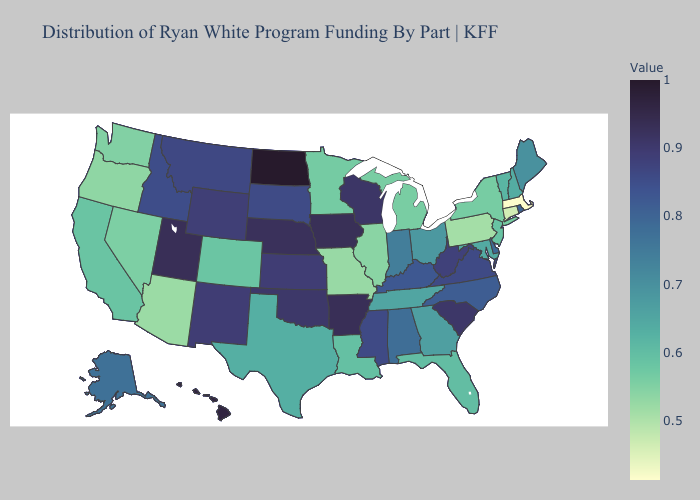Among the states that border Wisconsin , does Minnesota have the highest value?
Keep it brief. No. Which states hav the highest value in the South?
Give a very brief answer. Arkansas. Does the map have missing data?
Answer briefly. No. Among the states that border North Dakota , which have the highest value?
Be succinct. Montana. Does Illinois have the lowest value in the MidWest?
Write a very short answer. No. Is the legend a continuous bar?
Quick response, please. Yes. Among the states that border Ohio , which have the lowest value?
Keep it brief. Pennsylvania. 